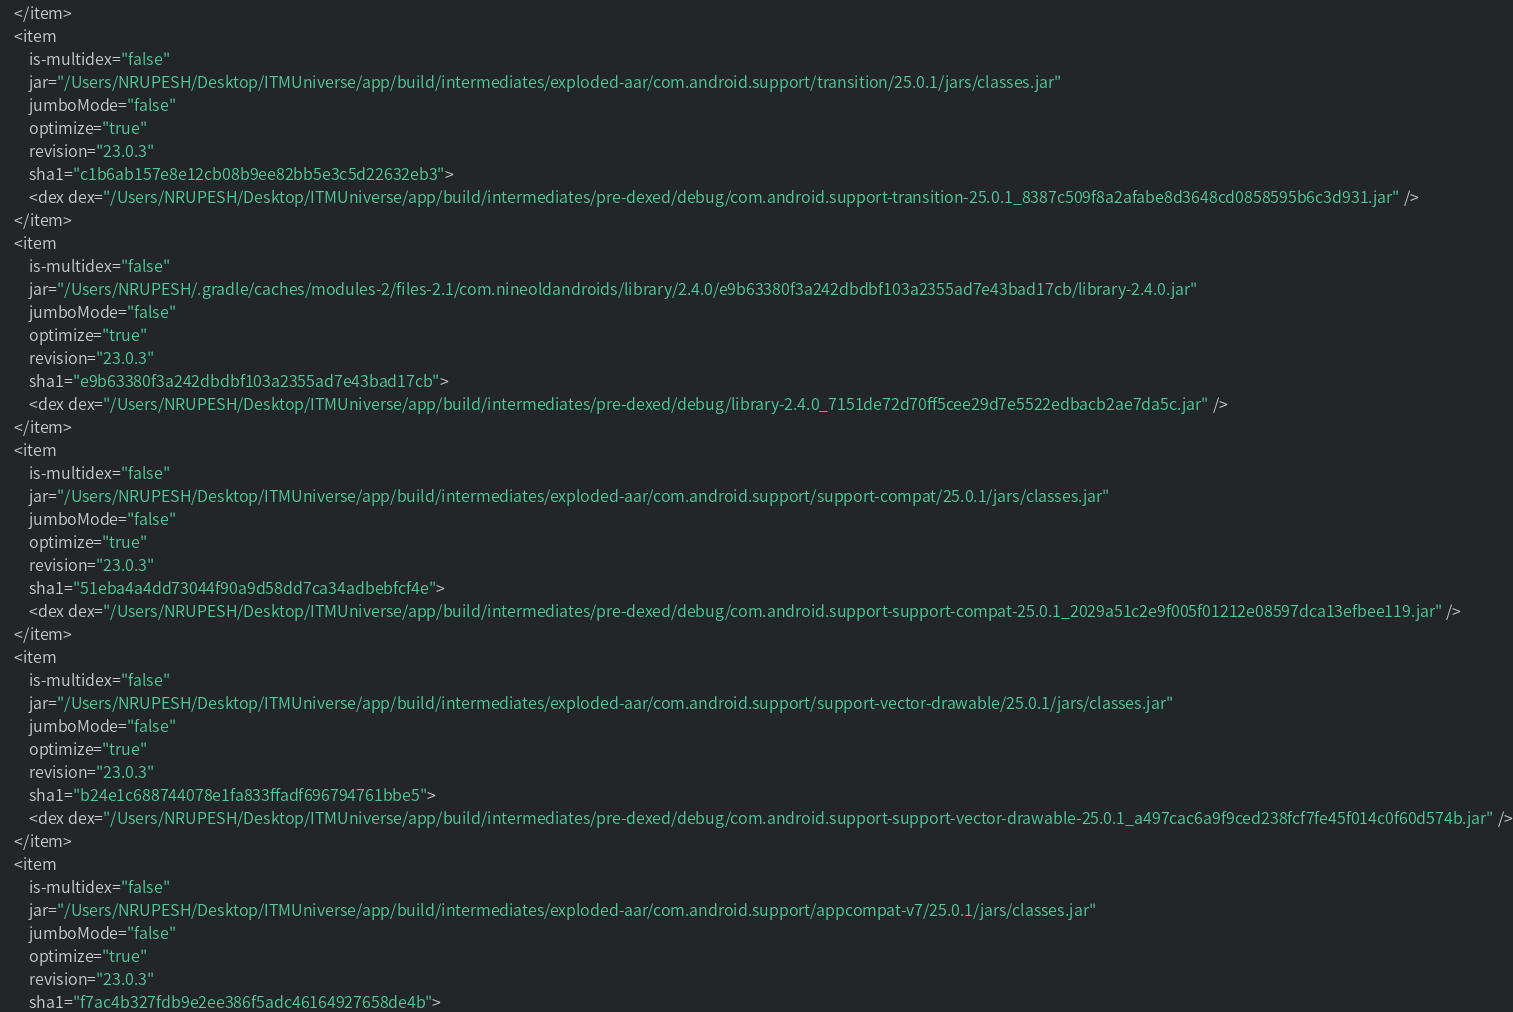Convert code to text. <code><loc_0><loc_0><loc_500><loc_500><_XML_>    </item>
    <item
        is-multidex="false"
        jar="/Users/NRUPESH/Desktop/ITMUniverse/app/build/intermediates/exploded-aar/com.android.support/transition/25.0.1/jars/classes.jar"
        jumboMode="false"
        optimize="true"
        revision="23.0.3"
        sha1="c1b6ab157e8e12cb08b9ee82bb5e3c5d22632eb3">
        <dex dex="/Users/NRUPESH/Desktop/ITMUniverse/app/build/intermediates/pre-dexed/debug/com.android.support-transition-25.0.1_8387c509f8a2afabe8d3648cd0858595b6c3d931.jar" />
    </item>
    <item
        is-multidex="false"
        jar="/Users/NRUPESH/.gradle/caches/modules-2/files-2.1/com.nineoldandroids/library/2.4.0/e9b63380f3a242dbdbf103a2355ad7e43bad17cb/library-2.4.0.jar"
        jumboMode="false"
        optimize="true"
        revision="23.0.3"
        sha1="e9b63380f3a242dbdbf103a2355ad7e43bad17cb">
        <dex dex="/Users/NRUPESH/Desktop/ITMUniverse/app/build/intermediates/pre-dexed/debug/library-2.4.0_7151de72d70ff5cee29d7e5522edbacb2ae7da5c.jar" />
    </item>
    <item
        is-multidex="false"
        jar="/Users/NRUPESH/Desktop/ITMUniverse/app/build/intermediates/exploded-aar/com.android.support/support-compat/25.0.1/jars/classes.jar"
        jumboMode="false"
        optimize="true"
        revision="23.0.3"
        sha1="51eba4a4dd73044f90a9d58dd7ca34adbebfcf4e">
        <dex dex="/Users/NRUPESH/Desktop/ITMUniverse/app/build/intermediates/pre-dexed/debug/com.android.support-support-compat-25.0.1_2029a51c2e9f005f01212e08597dca13efbee119.jar" />
    </item>
    <item
        is-multidex="false"
        jar="/Users/NRUPESH/Desktop/ITMUniverse/app/build/intermediates/exploded-aar/com.android.support/support-vector-drawable/25.0.1/jars/classes.jar"
        jumboMode="false"
        optimize="true"
        revision="23.0.3"
        sha1="b24e1c688744078e1fa833ffadf696794761bbe5">
        <dex dex="/Users/NRUPESH/Desktop/ITMUniverse/app/build/intermediates/pre-dexed/debug/com.android.support-support-vector-drawable-25.0.1_a497cac6a9f9ced238fcf7fe45f014c0f60d574b.jar" />
    </item>
    <item
        is-multidex="false"
        jar="/Users/NRUPESH/Desktop/ITMUniverse/app/build/intermediates/exploded-aar/com.android.support/appcompat-v7/25.0.1/jars/classes.jar"
        jumboMode="false"
        optimize="true"
        revision="23.0.3"
        sha1="f7ac4b327fdb9e2ee386f5adc46164927658de4b"></code> 